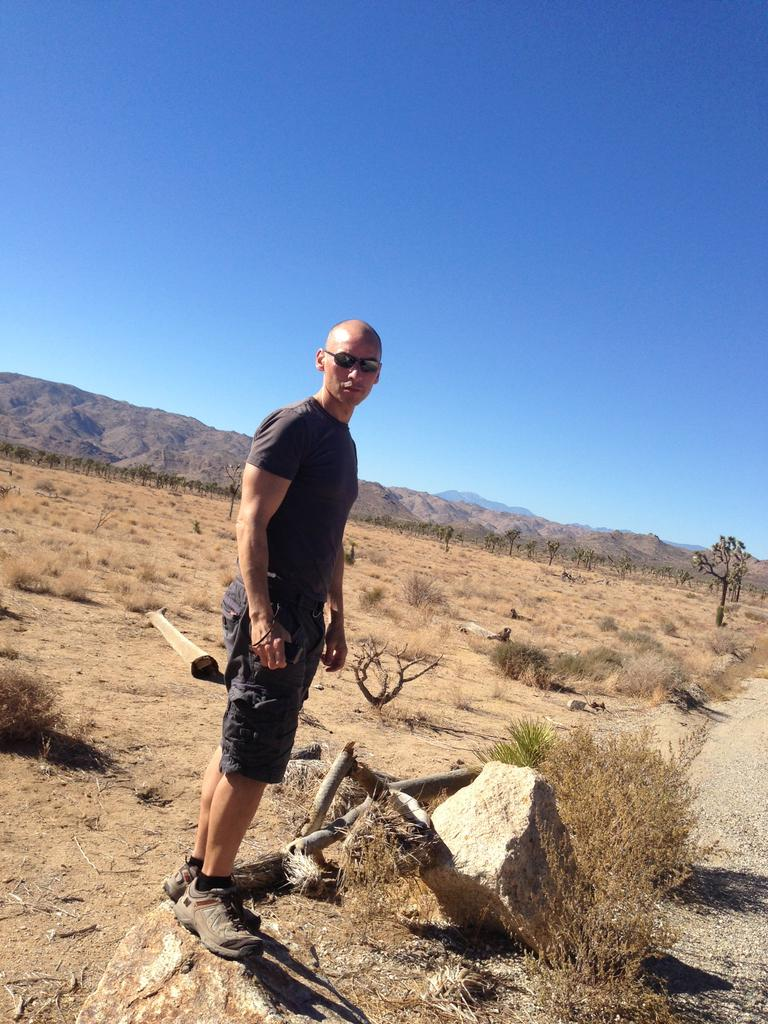What is the main subject of the image? There is a man standing in the image. Where is the man standing? The man is standing on the ground. What type of natural features can be seen in the image? Rocks, trees, and mountains are visible in the image. What is visible in the background of the image? The sky is visible in the background of the image. What type of quilt is being used to cover the rocks in the image? There is no quilt present in the image; the rocks are not covered. 